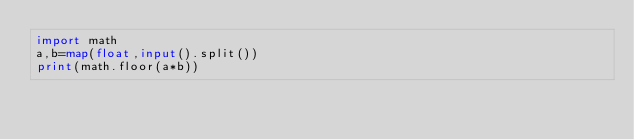<code> <loc_0><loc_0><loc_500><loc_500><_Python_>import math
a,b=map(float,input().split())
print(math.floor(a*b))
</code> 